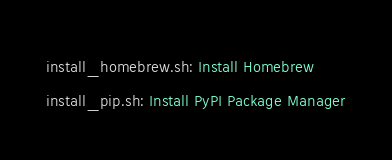Convert code to text. <code><loc_0><loc_0><loc_500><loc_500><_Ruby_>install_homebrew.sh: Install Homebrew
install_pip.sh: Install PyPI Package Manager</code> 